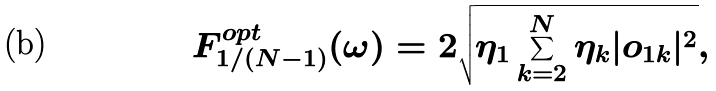<formula> <loc_0><loc_0><loc_500><loc_500>F ^ { o p t } _ { 1 / ( N - 1 ) } ( \omega ) = 2 \sqrt { \eta _ { 1 } \sum _ { k = 2 } ^ { N } \eta _ { k } | o _ { 1 k } | ^ { 2 } } ,</formula> 